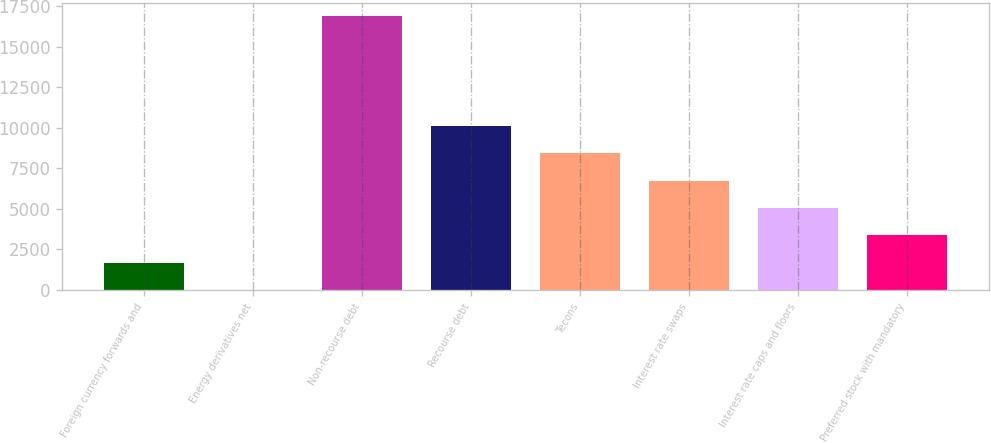Convert chart. <chart><loc_0><loc_0><loc_500><loc_500><bar_chart><fcel>Foreign currency forwards and<fcel>Energy derivatives net<fcel>Non-recourse debt<fcel>Recourse debt<fcel>Tecons<fcel>Interest rate swaps<fcel>Interest rate caps and floors<fcel>Preferred stock with mandatory<nl><fcel>1692<fcel>7<fcel>16857<fcel>10117<fcel>8432<fcel>6747<fcel>5062<fcel>3377<nl></chart> 